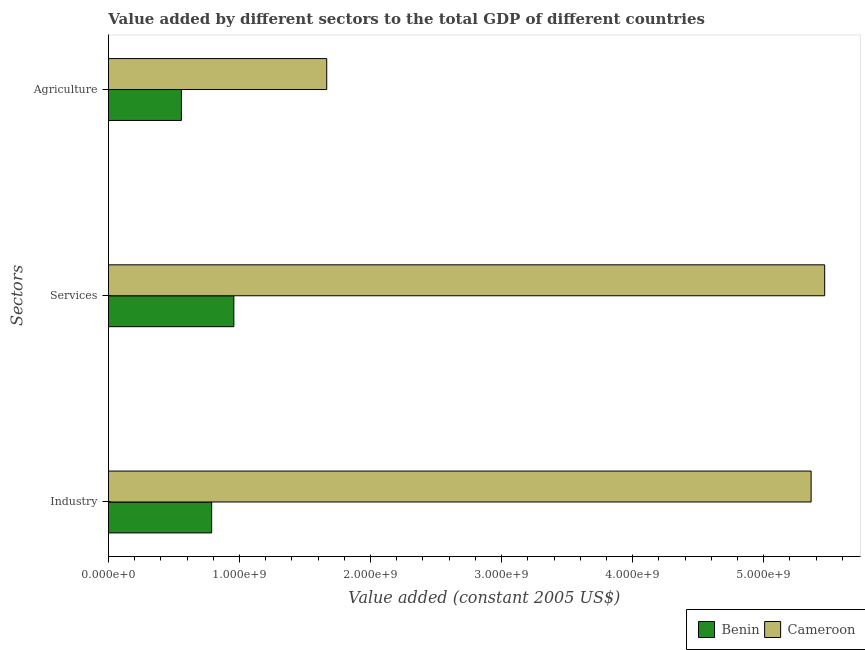How many groups of bars are there?
Your response must be concise. 3. Are the number of bars on each tick of the Y-axis equal?
Offer a terse response. Yes. How many bars are there on the 1st tick from the top?
Make the answer very short. 2. What is the label of the 1st group of bars from the top?
Your answer should be compact. Agriculture. What is the value added by industrial sector in Benin?
Make the answer very short. 7.88e+08. Across all countries, what is the maximum value added by services?
Ensure brevity in your answer.  5.47e+09. Across all countries, what is the minimum value added by agricultural sector?
Your answer should be very brief. 5.57e+08. In which country was the value added by services maximum?
Provide a short and direct response. Cameroon. In which country was the value added by services minimum?
Offer a terse response. Benin. What is the total value added by services in the graph?
Your answer should be compact. 6.42e+09. What is the difference between the value added by industrial sector in Cameroon and that in Benin?
Your answer should be very brief. 4.57e+09. What is the difference between the value added by industrial sector in Cameroon and the value added by agricultural sector in Benin?
Keep it short and to the point. 4.80e+09. What is the average value added by services per country?
Your answer should be very brief. 3.21e+09. What is the difference between the value added by services and value added by agricultural sector in Cameroon?
Your answer should be compact. 3.80e+09. In how many countries, is the value added by agricultural sector greater than 4600000000 US$?
Keep it short and to the point. 0. What is the ratio of the value added by agricultural sector in Benin to that in Cameroon?
Give a very brief answer. 0.33. Is the value added by agricultural sector in Cameroon less than that in Benin?
Provide a short and direct response. No. Is the difference between the value added by agricultural sector in Cameroon and Benin greater than the difference between the value added by industrial sector in Cameroon and Benin?
Give a very brief answer. No. What is the difference between the highest and the second highest value added by services?
Provide a succinct answer. 4.51e+09. What is the difference between the highest and the lowest value added by agricultural sector?
Your response must be concise. 1.11e+09. In how many countries, is the value added by industrial sector greater than the average value added by industrial sector taken over all countries?
Offer a very short reply. 1. Is the sum of the value added by industrial sector in Cameroon and Benin greater than the maximum value added by services across all countries?
Offer a very short reply. Yes. What does the 1st bar from the top in Agriculture represents?
Give a very brief answer. Cameroon. What does the 1st bar from the bottom in Services represents?
Your answer should be compact. Benin. Are all the bars in the graph horizontal?
Offer a very short reply. Yes. What is the difference between two consecutive major ticks on the X-axis?
Your answer should be compact. 1.00e+09. Are the values on the major ticks of X-axis written in scientific E-notation?
Give a very brief answer. Yes. Does the graph contain any zero values?
Keep it short and to the point. No. What is the title of the graph?
Your answer should be compact. Value added by different sectors to the total GDP of different countries. What is the label or title of the X-axis?
Offer a terse response. Value added (constant 2005 US$). What is the label or title of the Y-axis?
Offer a terse response. Sectors. What is the Value added (constant 2005 US$) in Benin in Industry?
Ensure brevity in your answer.  7.88e+08. What is the Value added (constant 2005 US$) in Cameroon in Industry?
Offer a terse response. 5.36e+09. What is the Value added (constant 2005 US$) of Benin in Services?
Your answer should be very brief. 9.57e+08. What is the Value added (constant 2005 US$) in Cameroon in Services?
Your answer should be very brief. 5.47e+09. What is the Value added (constant 2005 US$) in Benin in Agriculture?
Keep it short and to the point. 5.57e+08. What is the Value added (constant 2005 US$) in Cameroon in Agriculture?
Give a very brief answer. 1.67e+09. Across all Sectors, what is the maximum Value added (constant 2005 US$) of Benin?
Keep it short and to the point. 9.57e+08. Across all Sectors, what is the maximum Value added (constant 2005 US$) of Cameroon?
Provide a succinct answer. 5.47e+09. Across all Sectors, what is the minimum Value added (constant 2005 US$) in Benin?
Keep it short and to the point. 5.57e+08. Across all Sectors, what is the minimum Value added (constant 2005 US$) in Cameroon?
Your answer should be very brief. 1.67e+09. What is the total Value added (constant 2005 US$) of Benin in the graph?
Give a very brief answer. 2.30e+09. What is the total Value added (constant 2005 US$) of Cameroon in the graph?
Offer a terse response. 1.25e+1. What is the difference between the Value added (constant 2005 US$) of Benin in Industry and that in Services?
Provide a short and direct response. -1.69e+08. What is the difference between the Value added (constant 2005 US$) of Cameroon in Industry and that in Services?
Offer a very short reply. -1.03e+08. What is the difference between the Value added (constant 2005 US$) in Benin in Industry and that in Agriculture?
Provide a short and direct response. 2.31e+08. What is the difference between the Value added (constant 2005 US$) of Cameroon in Industry and that in Agriculture?
Your answer should be compact. 3.70e+09. What is the difference between the Value added (constant 2005 US$) in Benin in Services and that in Agriculture?
Keep it short and to the point. 4.00e+08. What is the difference between the Value added (constant 2005 US$) in Cameroon in Services and that in Agriculture?
Provide a short and direct response. 3.80e+09. What is the difference between the Value added (constant 2005 US$) in Benin in Industry and the Value added (constant 2005 US$) in Cameroon in Services?
Keep it short and to the point. -4.68e+09. What is the difference between the Value added (constant 2005 US$) of Benin in Industry and the Value added (constant 2005 US$) of Cameroon in Agriculture?
Your answer should be very brief. -8.78e+08. What is the difference between the Value added (constant 2005 US$) in Benin in Services and the Value added (constant 2005 US$) in Cameroon in Agriculture?
Your answer should be compact. -7.09e+08. What is the average Value added (constant 2005 US$) in Benin per Sectors?
Keep it short and to the point. 7.67e+08. What is the average Value added (constant 2005 US$) of Cameroon per Sectors?
Offer a terse response. 4.16e+09. What is the difference between the Value added (constant 2005 US$) in Benin and Value added (constant 2005 US$) in Cameroon in Industry?
Your answer should be compact. -4.57e+09. What is the difference between the Value added (constant 2005 US$) in Benin and Value added (constant 2005 US$) in Cameroon in Services?
Give a very brief answer. -4.51e+09. What is the difference between the Value added (constant 2005 US$) in Benin and Value added (constant 2005 US$) in Cameroon in Agriculture?
Ensure brevity in your answer.  -1.11e+09. What is the ratio of the Value added (constant 2005 US$) of Benin in Industry to that in Services?
Your answer should be compact. 0.82. What is the ratio of the Value added (constant 2005 US$) in Cameroon in Industry to that in Services?
Your answer should be compact. 0.98. What is the ratio of the Value added (constant 2005 US$) in Benin in Industry to that in Agriculture?
Your answer should be very brief. 1.41. What is the ratio of the Value added (constant 2005 US$) of Cameroon in Industry to that in Agriculture?
Keep it short and to the point. 3.22. What is the ratio of the Value added (constant 2005 US$) in Benin in Services to that in Agriculture?
Your answer should be very brief. 1.72. What is the ratio of the Value added (constant 2005 US$) in Cameroon in Services to that in Agriculture?
Your answer should be very brief. 3.28. What is the difference between the highest and the second highest Value added (constant 2005 US$) in Benin?
Provide a succinct answer. 1.69e+08. What is the difference between the highest and the second highest Value added (constant 2005 US$) of Cameroon?
Your answer should be very brief. 1.03e+08. What is the difference between the highest and the lowest Value added (constant 2005 US$) of Benin?
Offer a very short reply. 4.00e+08. What is the difference between the highest and the lowest Value added (constant 2005 US$) in Cameroon?
Your answer should be very brief. 3.80e+09. 